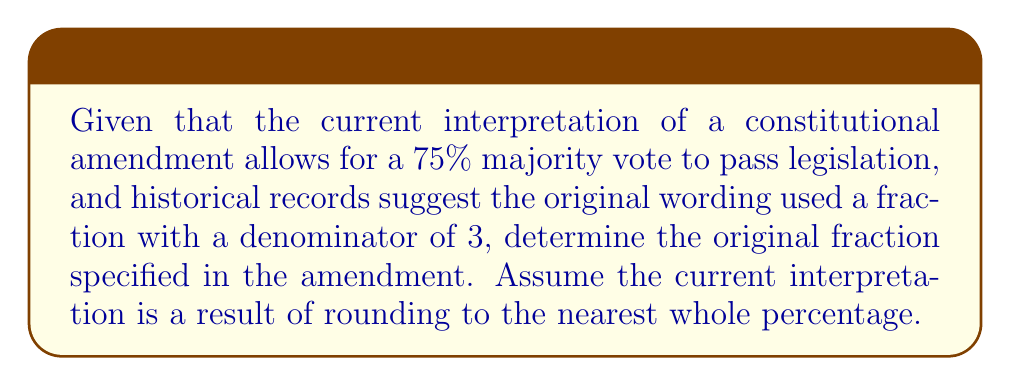Can you solve this math problem? To solve this inverse problem, we need to work backwards from the current interpretation to determine the original fraction. Let's approach this step-by-step:

1) The current interpretation allows for a $75\%$ majority vote.

2) We're told that the original wording used a fraction with a denominator of 3.

3) The possible fractions with a denominator of 3 are $\frac{1}{3}$, $\frac{2}{3}$, and $\frac{3}{3}$.

4) Let's convert these fractions to percentages:
   
   $\frac{1}{3} \approx 33.33\%$
   $\frac{2}{3} \approx 66.67\%$
   $\frac{3}{3} = 100\%$

5) The current interpretation (75%) is closest to $\frac{2}{3}$ (66.67%).

6) Rounding $\frac{2}{3}$ (66.67%) to the nearest whole percentage gives us 67%.

7) However, the question states that the current interpretation is 75%. This suggests that over time, the threshold has been increased for added stringency.

8) The original $\frac{2}{3}$ majority could have been interpreted as "at least two-thirds", which when rounded up to the nearest convenient percentage, became 75%.

Therefore, the original fraction specified in the amendment was most likely $\frac{2}{3}$.
Answer: $\frac{2}{3}$ 